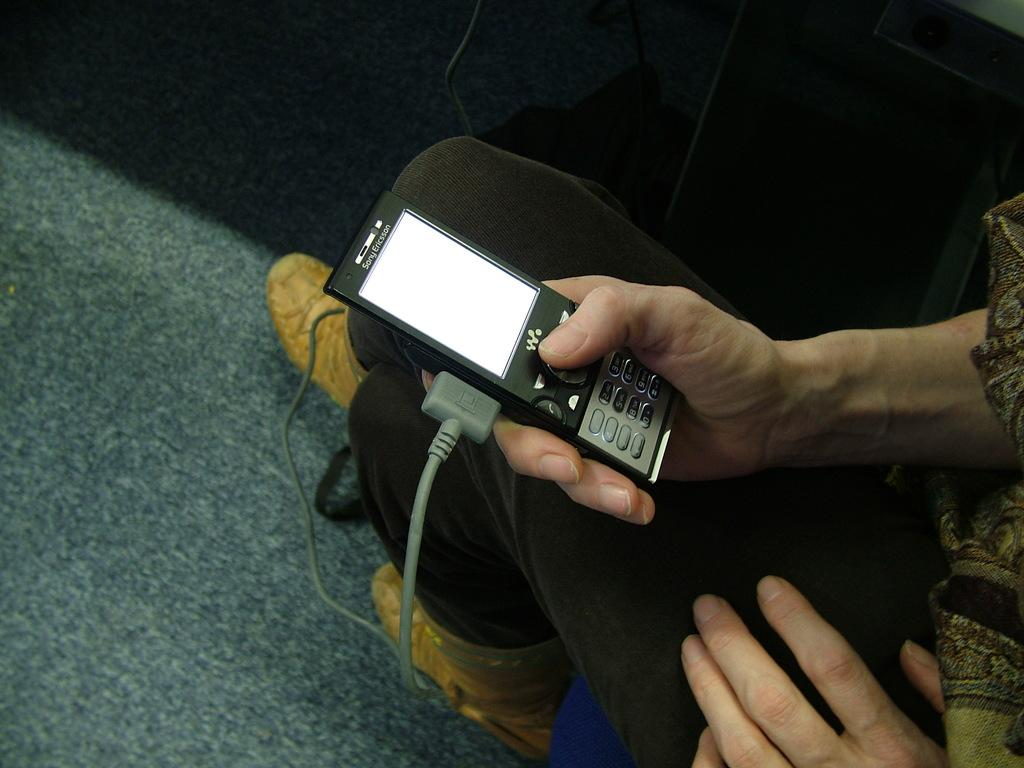What can be seen in the image? There is a person in the image. Can you describe the person's attire? The person is wearing clothes and shoes. What is the person holding in their hand? The person is holding a gadget in their hand. Is there anything else visible in the image? Yes, there is a cable wire visible in the image. What is the surface beneath the person? There is a floor in the image. What type of humor can be seen in the image? There is no humor present in the image; it is a straightforward depiction of a person holding a gadget. 